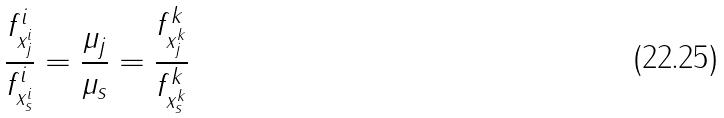<formula> <loc_0><loc_0><loc_500><loc_500>\frac { f _ { x _ { j } ^ { i } } ^ { i } } { f _ { x _ { s } ^ { i } } ^ { i } } = \frac { \mu _ { j } } { \mu _ { s } } = \frac { f _ { x _ { j } ^ { k } } ^ { k } } { f _ { x _ { s } ^ { k } } ^ { k } }</formula> 